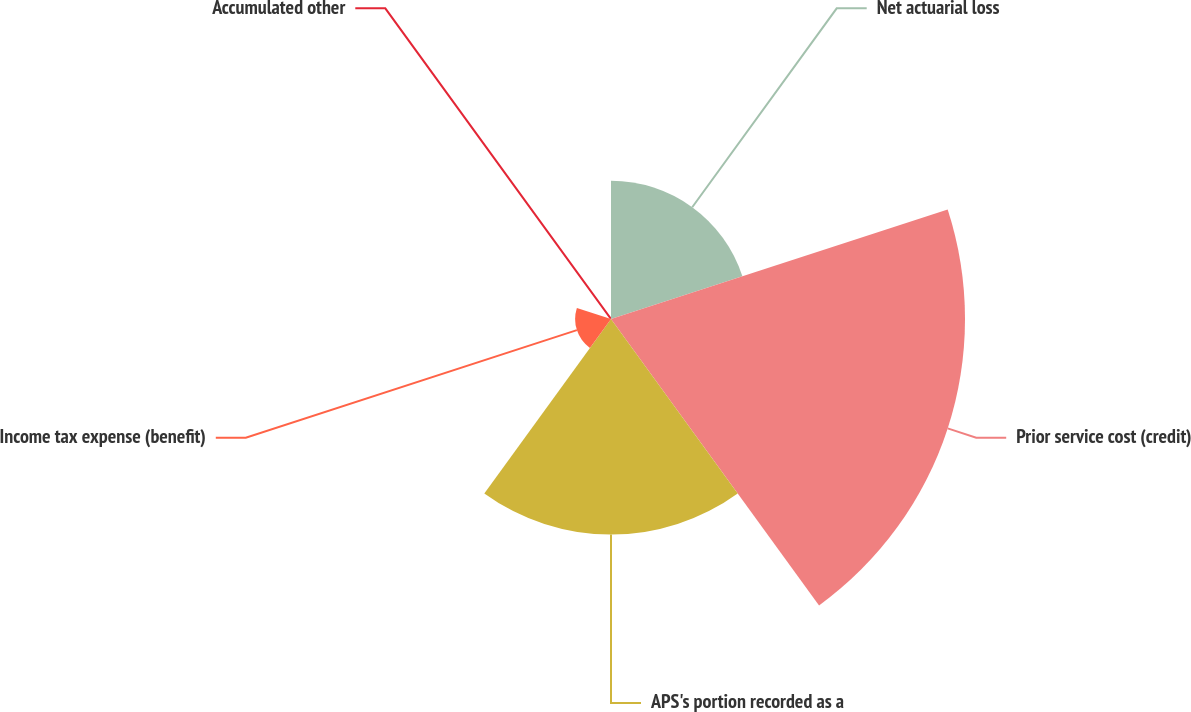Convert chart. <chart><loc_0><loc_0><loc_500><loc_500><pie_chart><fcel>Net actuarial loss<fcel>Prior service cost (credit)<fcel>APS's portion recorded as a<fcel>Income tax expense (benefit)<fcel>Accumulated other<nl><fcel>18.57%<fcel>47.58%<fcel>28.97%<fcel>4.82%<fcel>0.06%<nl></chart> 